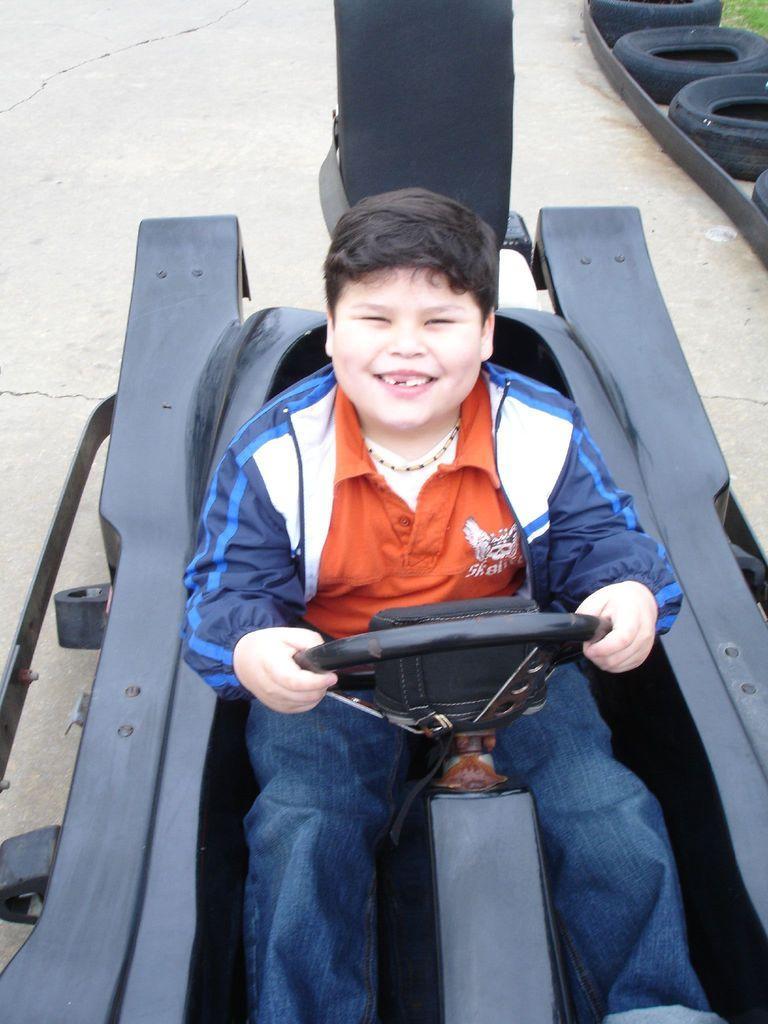Describe this image in one or two sentences. A boy is riding the vehicle, he wore red color t-shirt, blue color jeans. He is smiling. 